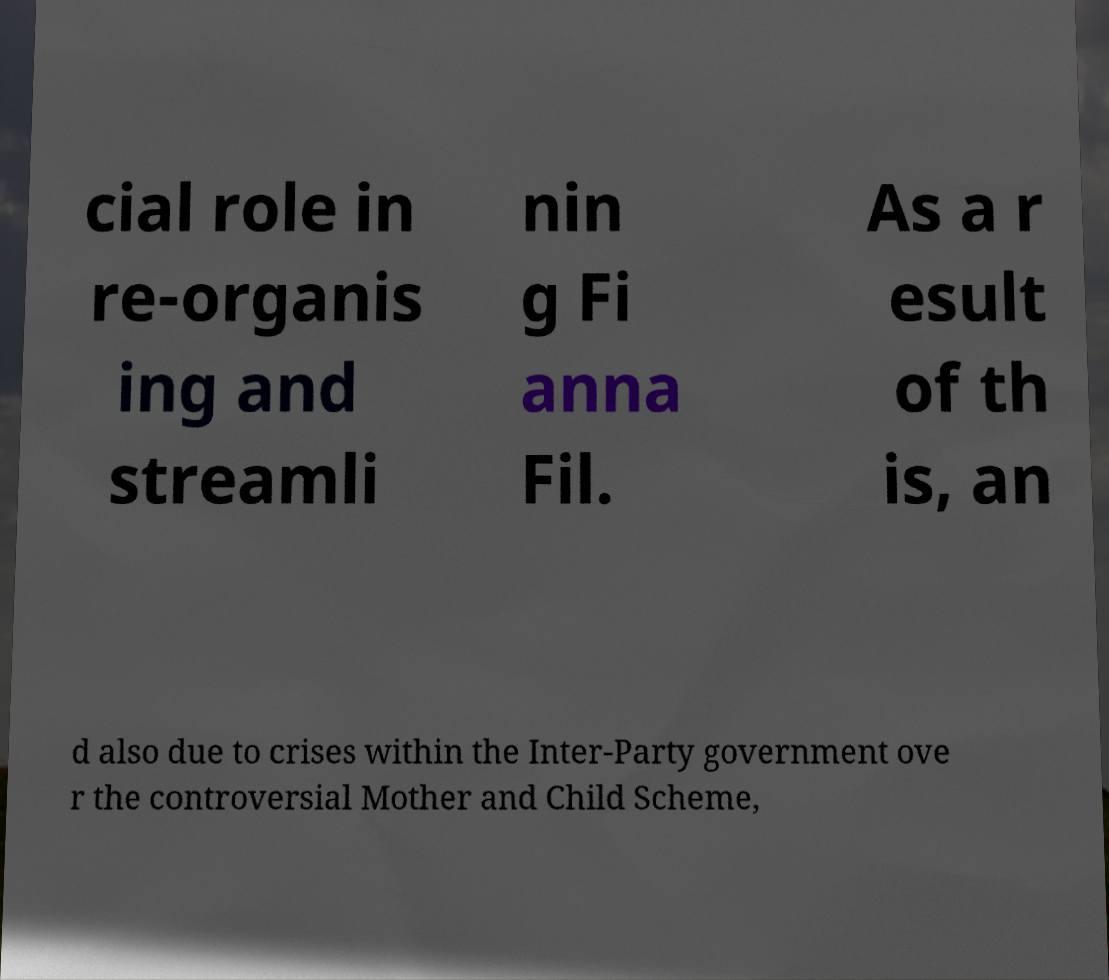For documentation purposes, I need the text within this image transcribed. Could you provide that? cial role in re-organis ing and streamli nin g Fi anna Fil. As a r esult of th is, an d also due to crises within the Inter-Party government ove r the controversial Mother and Child Scheme, 